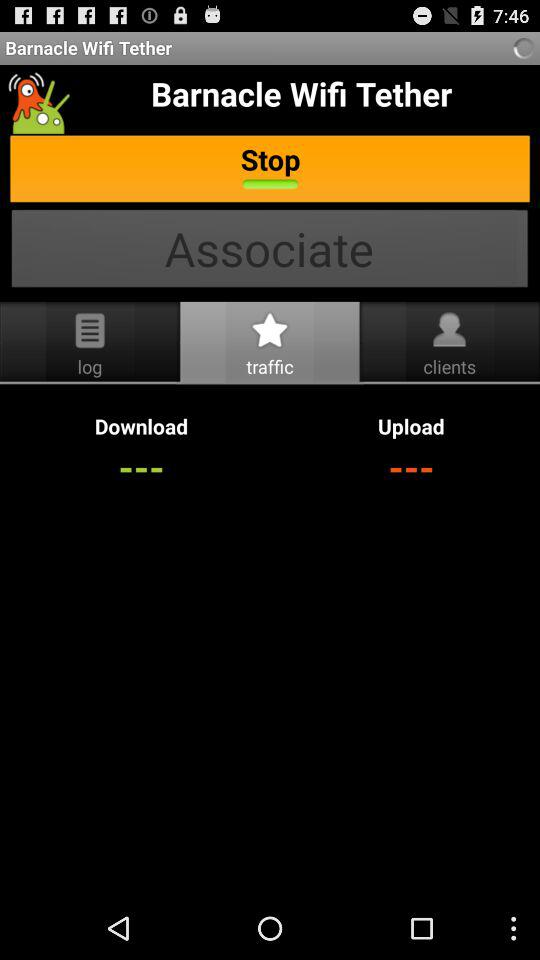What is the name of the application? The name of the application is "Barnacle Wifi Tether". 